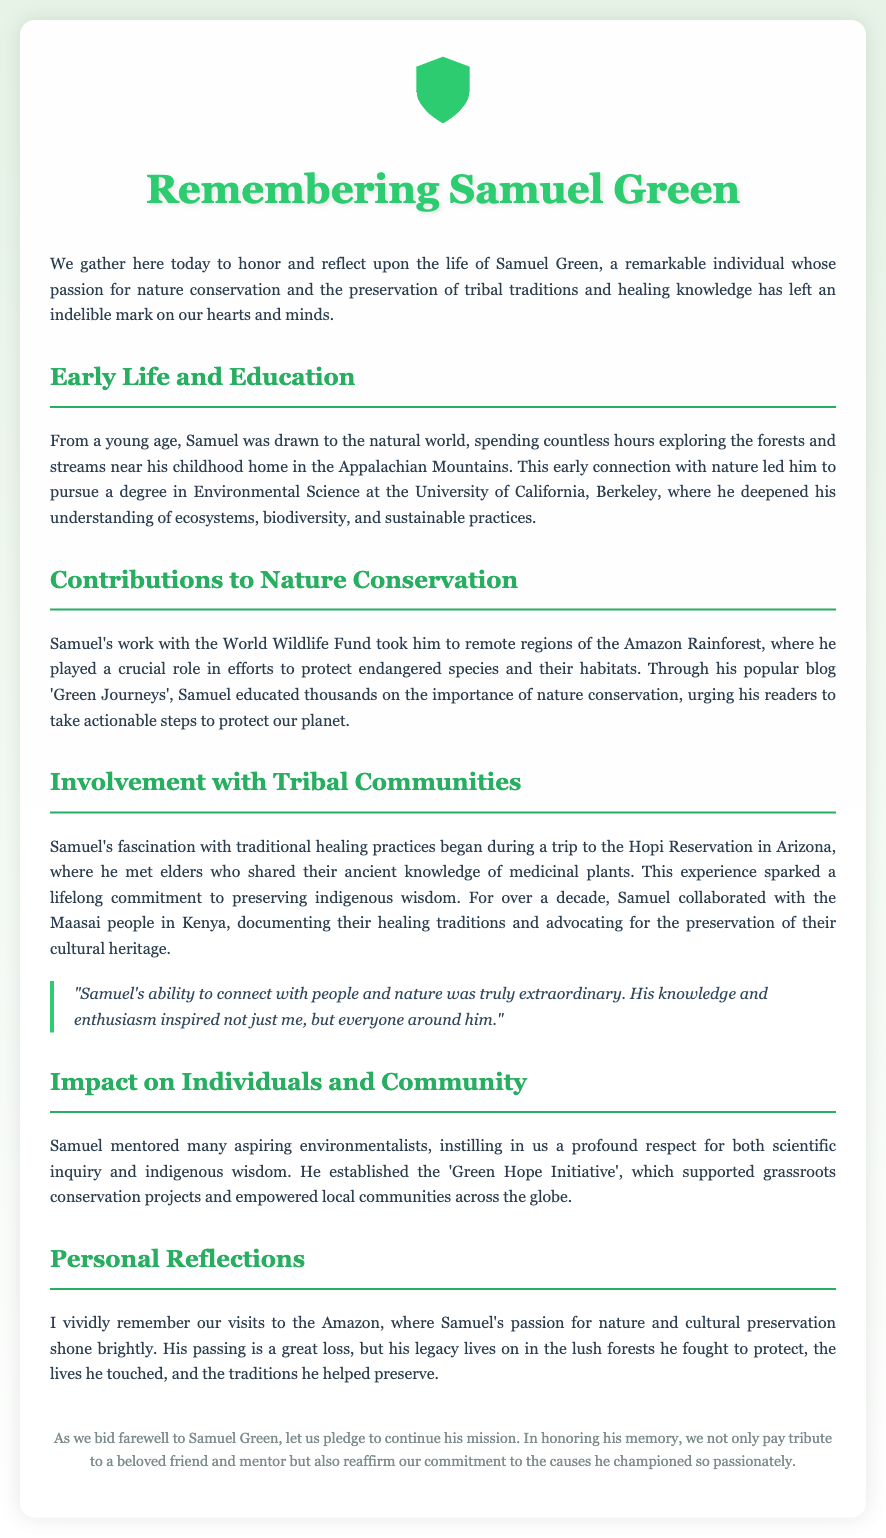What degree did Samuel pursue? The document states that Samuel pursued a degree in Environmental Science at the University of California, Berkeley.
Answer: Environmental Science Where did Samuel work during his conservation efforts? It mentions that Samuel worked with the World Wildlife Fund in remote regions of the Amazon Rainforest.
Answer: Amazon Rainforest What was the name of Samuel's blog? The eulogy refers to his blog as 'Green Journeys' where he educated people about nature conservation.
Answer: Green Journeys Who did Samuel collaborate with in Kenya? The document highlights that Samuel collaborated with the Maasai people in Kenya to document their healing traditions.
Answer: Maasai people What initiative did Samuel establish? The eulogy mentions the 'Green Hope Initiative' that supported grassroots conservation projects.
Answer: Green Hope Initiative How long did Samuel's commitment to indigenous wisdom last? It notes that his commitment lasted over a decade while working with tribal communities.
Answer: Over a decade What type of plants did Samuel learn about at the Hopi Reservation? The document indicates that Samuel learned about medicinal plants during his visit to the Hopi Reservation.
Answer: Medicinal plants What is one of Samuel's extraordinary qualities according to the quote? The quote in the document highlights his ability to connect with people and nature as truly extraordinary.
Answer: Connect with people and nature What does the document ask us to pledge in Samuel's memory? It asks us to continue his mission and reaffirm our commitment to the causes he championed.
Answer: Continue his mission 